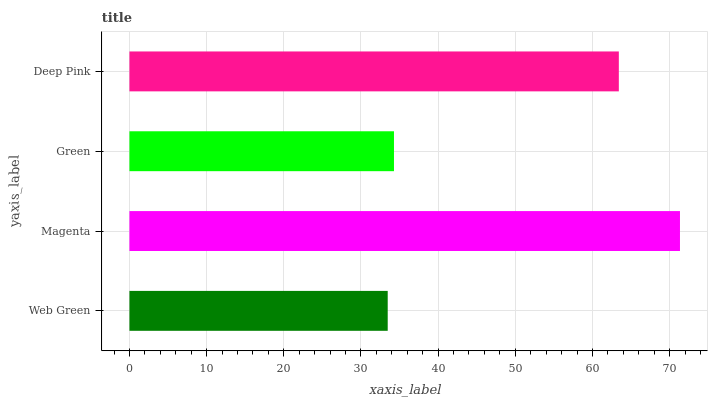Is Web Green the minimum?
Answer yes or no. Yes. Is Magenta the maximum?
Answer yes or no. Yes. Is Green the minimum?
Answer yes or no. No. Is Green the maximum?
Answer yes or no. No. Is Magenta greater than Green?
Answer yes or no. Yes. Is Green less than Magenta?
Answer yes or no. Yes. Is Green greater than Magenta?
Answer yes or no. No. Is Magenta less than Green?
Answer yes or no. No. Is Deep Pink the high median?
Answer yes or no. Yes. Is Green the low median?
Answer yes or no. Yes. Is Green the high median?
Answer yes or no. No. Is Web Green the low median?
Answer yes or no. No. 